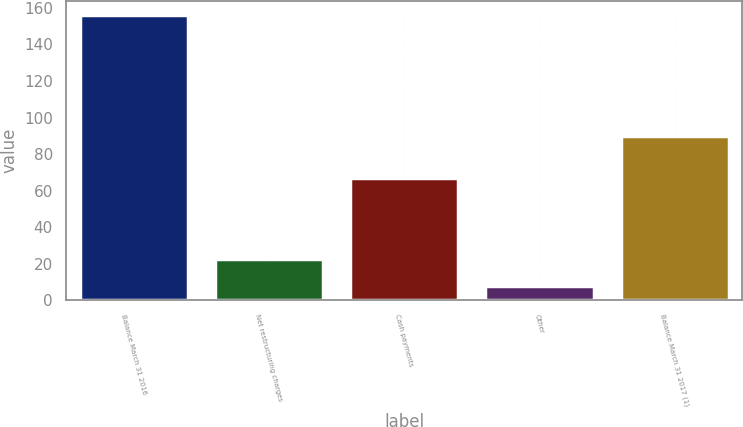Convert chart to OTSL. <chart><loc_0><loc_0><loc_500><loc_500><bar_chart><fcel>Balance March 31 2016<fcel>Net restructuring charges<fcel>Cash payments<fcel>Other<fcel>Balance March 31 2017 (1)<nl><fcel>156<fcel>22.8<fcel>67<fcel>8<fcel>90<nl></chart> 